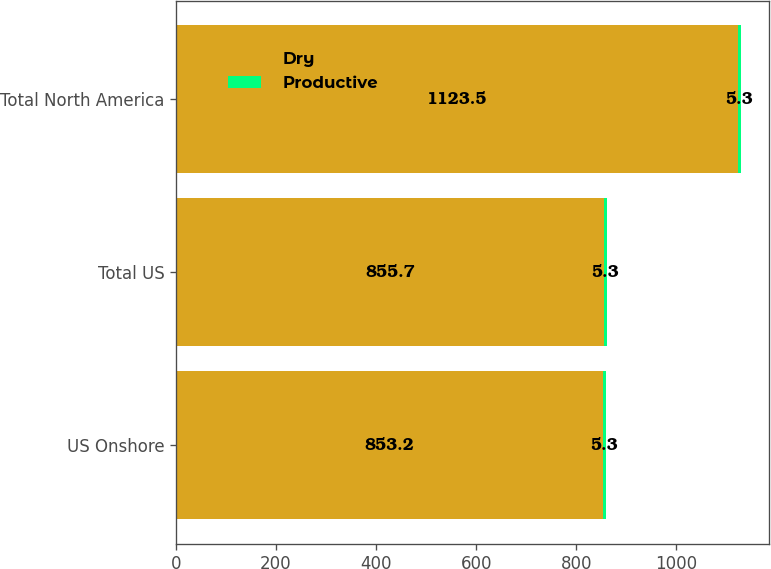Convert chart. <chart><loc_0><loc_0><loc_500><loc_500><stacked_bar_chart><ecel><fcel>US Onshore<fcel>Total US<fcel>Total North America<nl><fcel>Dry<fcel>853.2<fcel>855.7<fcel>1123.5<nl><fcel>Productive<fcel>5.3<fcel>5.3<fcel>5.3<nl></chart> 